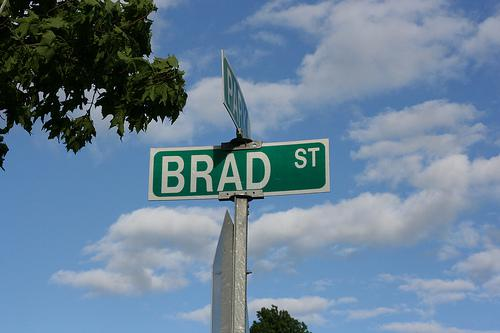Question: what color are the clouds?
Choices:
A. White.
B. Red.
C. Green.
D. Black.
Answer with the letter. Answer: A Question: where was the photo taken?
Choices:
A. On the highway.
B. At an intersection.
C. On a sidewalk next to a road.
D. On a bridge.
Answer with the letter. Answer: B Question: what color are the skies?
Choices:
A. Red.
B. Blue.
C. White.
D. Black.
Answer with the letter. Answer: B Question: what color are the leaves?
Choices:
A. Green.
B. Yellow.
C. Brown.
D. Beige.
Answer with the letter. Answer: A 